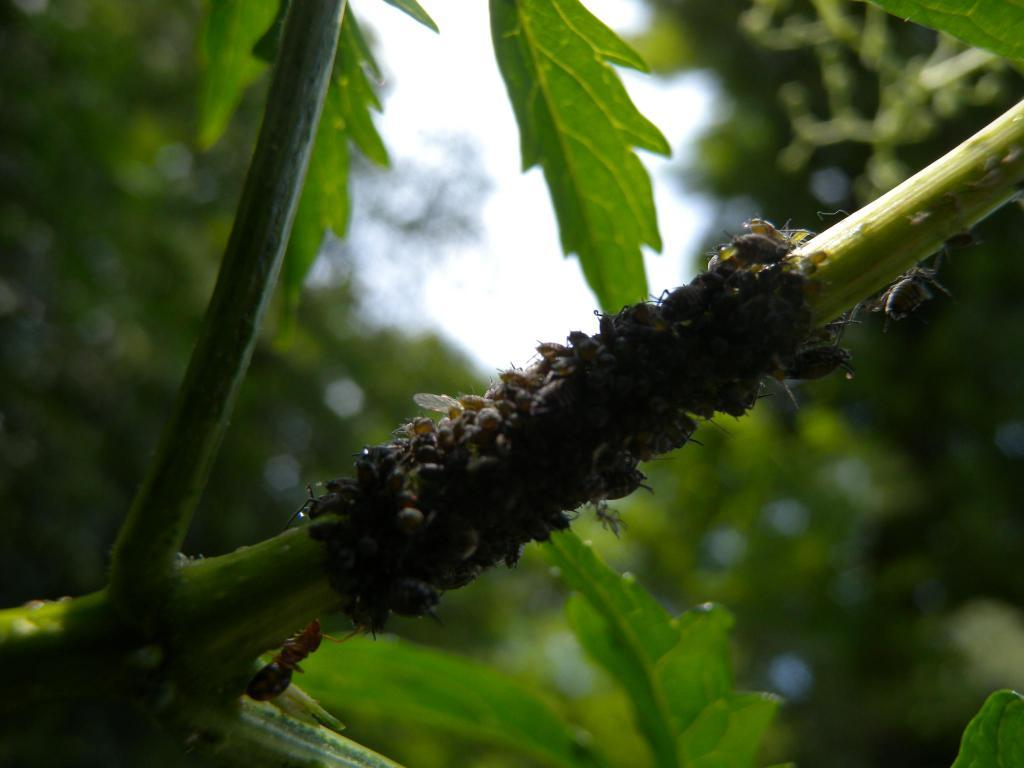What type of creatures can be seen in the image? There are insects in the image. Where are the insects located? The insects are on a branch of a tree. Can you describe the background of the image? The background of the image is blurry. What type of land can be seen in the image? There is no specific type of land visible in the image, as the focus is on the insects and the blurry background. 